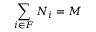Convert formula to latex. <formula><loc_0><loc_0><loc_500><loc_500>\sum _ { i \in F } N _ { i } = M</formula> 